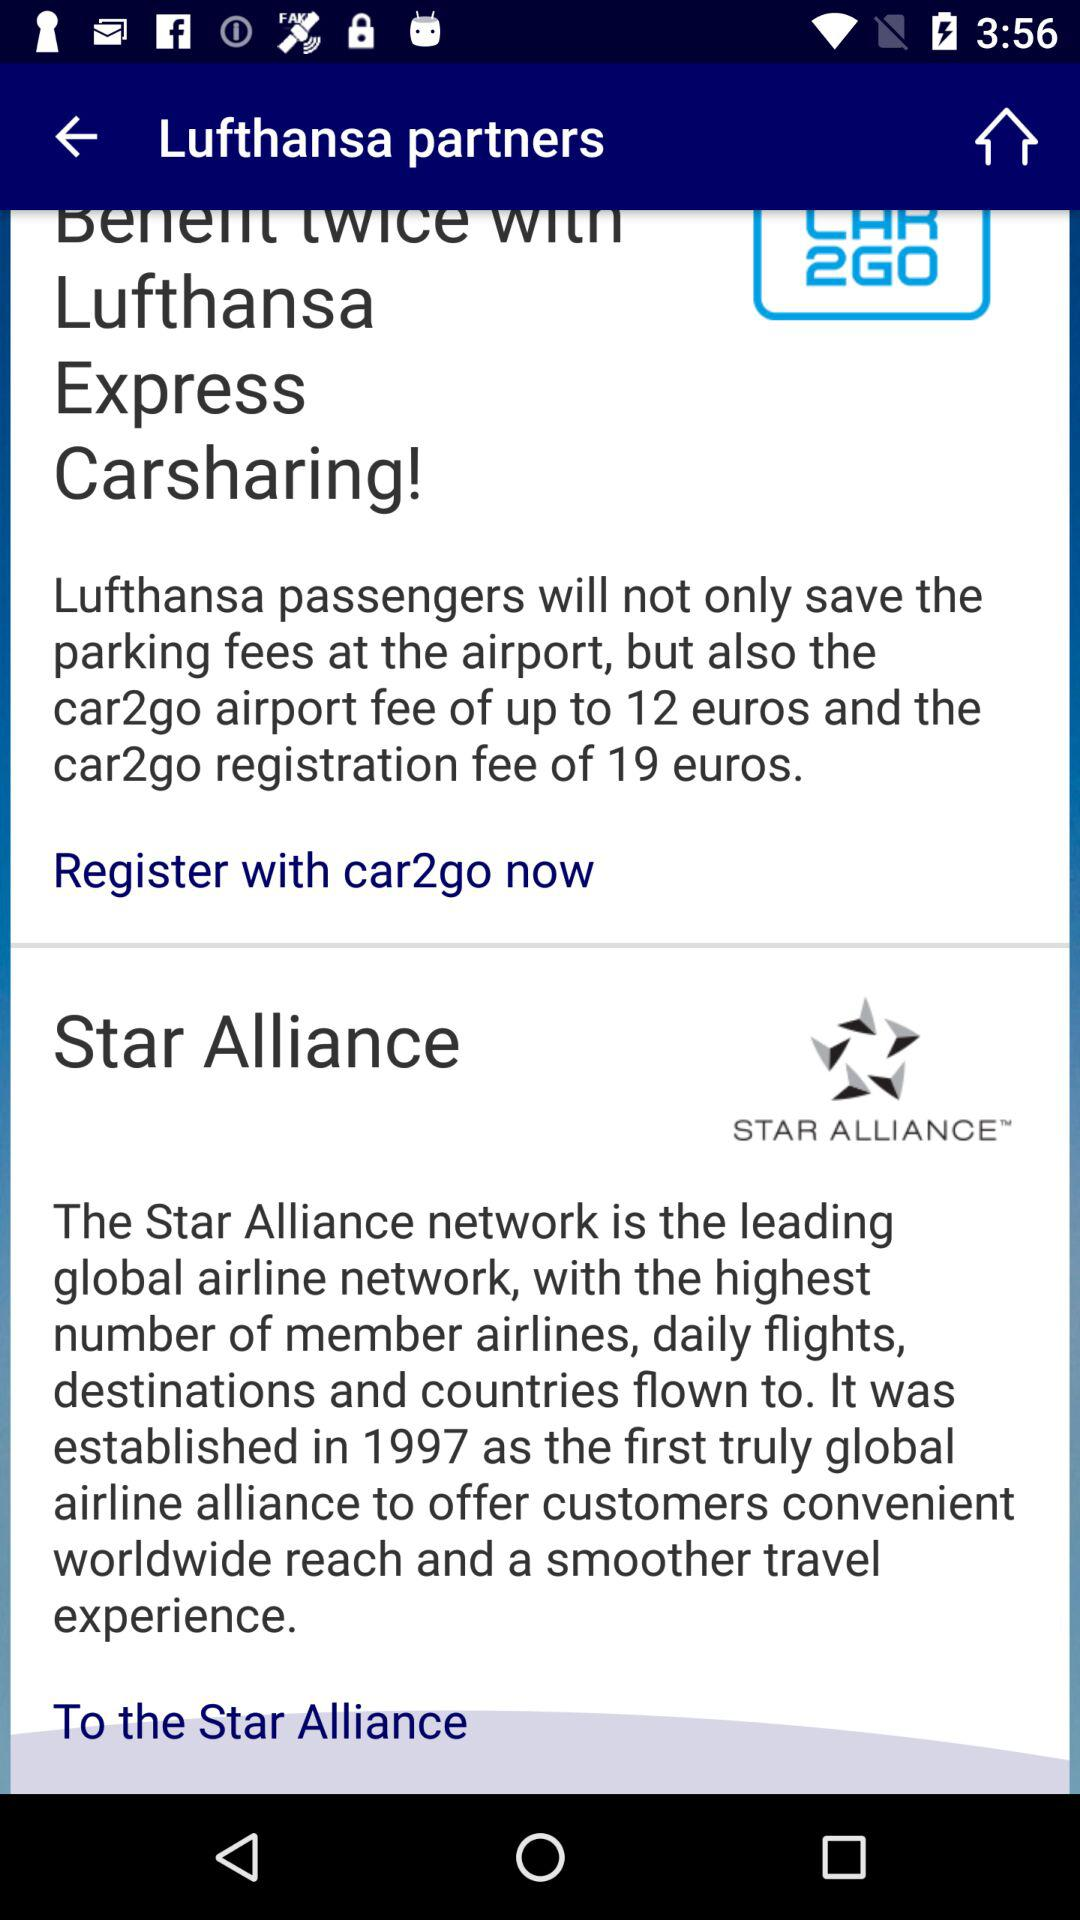When was the Star Alliance established? The Star Alliance was established in 1997. 